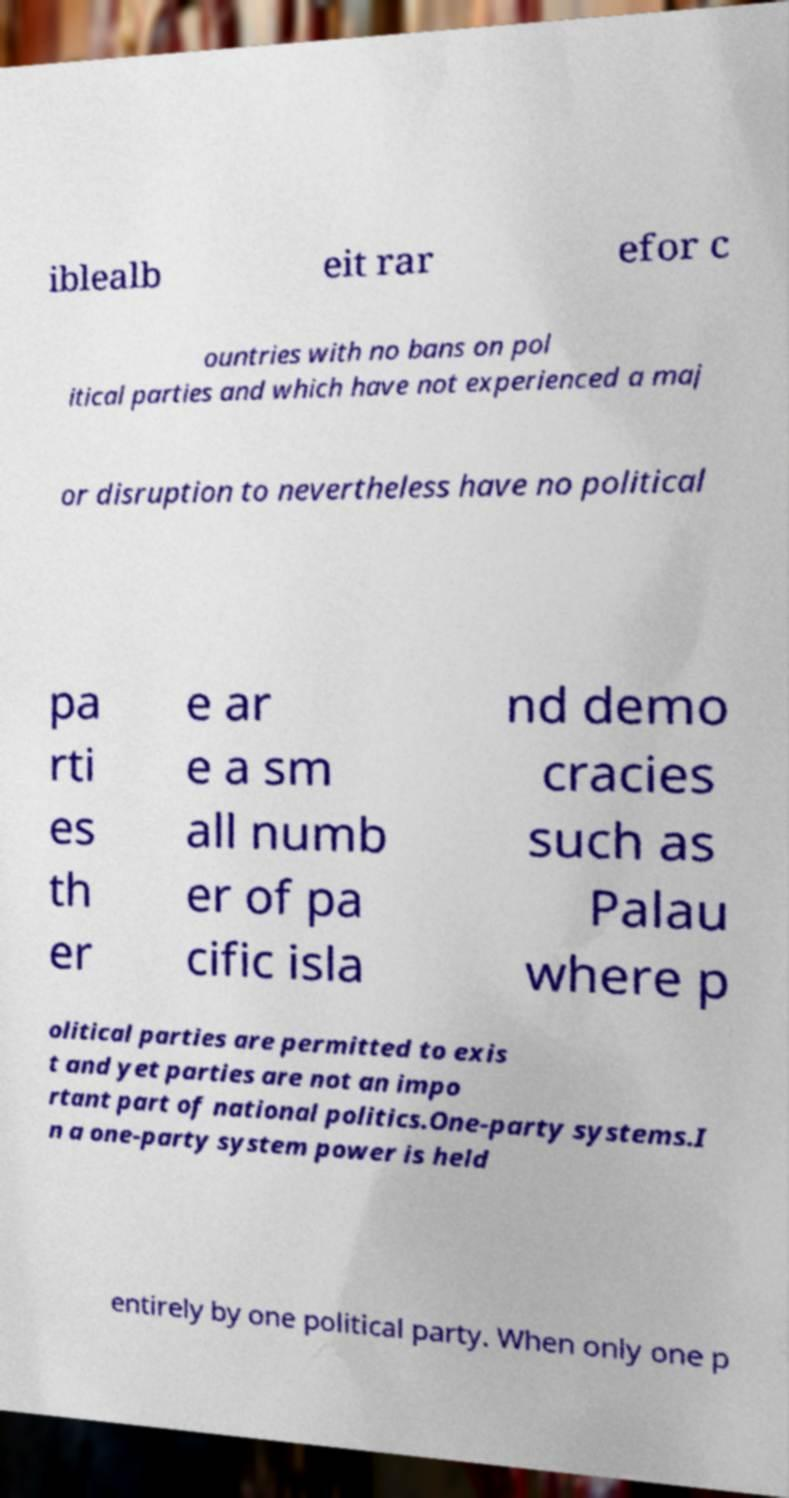I need the written content from this picture converted into text. Can you do that? iblealb eit rar efor c ountries with no bans on pol itical parties and which have not experienced a maj or disruption to nevertheless have no political pa rti es th er e ar e a sm all numb er of pa cific isla nd demo cracies such as Palau where p olitical parties are permitted to exis t and yet parties are not an impo rtant part of national politics.One-party systems.I n a one-party system power is held entirely by one political party. When only one p 